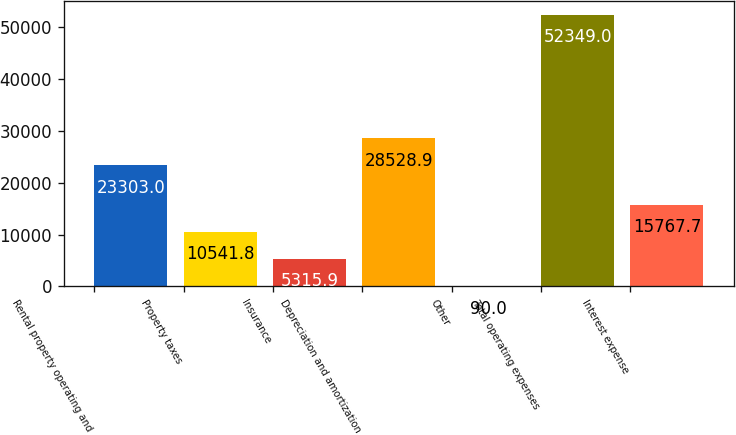Convert chart. <chart><loc_0><loc_0><loc_500><loc_500><bar_chart><fcel>Rental property operating and<fcel>Property taxes<fcel>Insurance<fcel>Depreciation and amortization<fcel>Other<fcel>Total operating expenses<fcel>Interest expense<nl><fcel>23303<fcel>10541.8<fcel>5315.9<fcel>28528.9<fcel>90<fcel>52349<fcel>15767.7<nl></chart> 